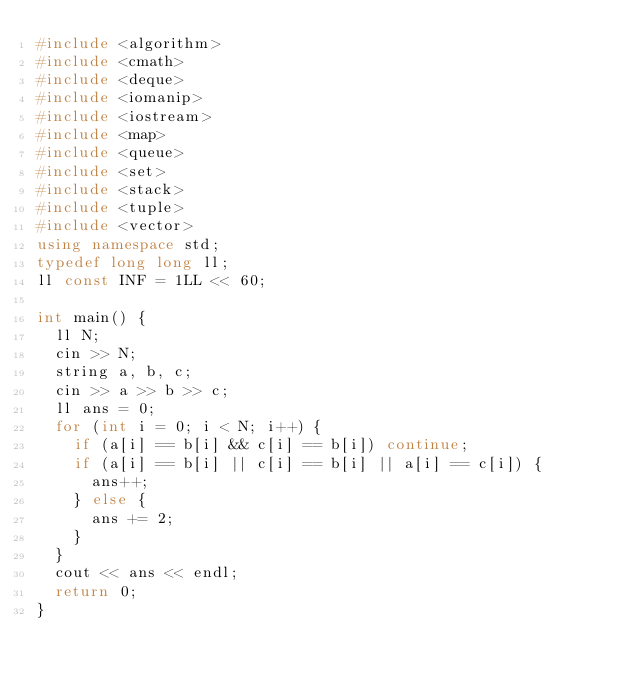<code> <loc_0><loc_0><loc_500><loc_500><_C++_>#include <algorithm>
#include <cmath>
#include <deque>
#include <iomanip>
#include <iostream>
#include <map>
#include <queue>
#include <set>
#include <stack>
#include <tuple>
#include <vector>
using namespace std;
typedef long long ll;
ll const INF = 1LL << 60;

int main() {
  ll N;
  cin >> N;
  string a, b, c;
  cin >> a >> b >> c;
  ll ans = 0;
  for (int i = 0; i < N; i++) {
    if (a[i] == b[i] && c[i] == b[i]) continue;
    if (a[i] == b[i] || c[i] == b[i] || a[i] == c[i]) {
      ans++;
    } else {
      ans += 2;
    }
  }
  cout << ans << endl;
  return 0;
}</code> 